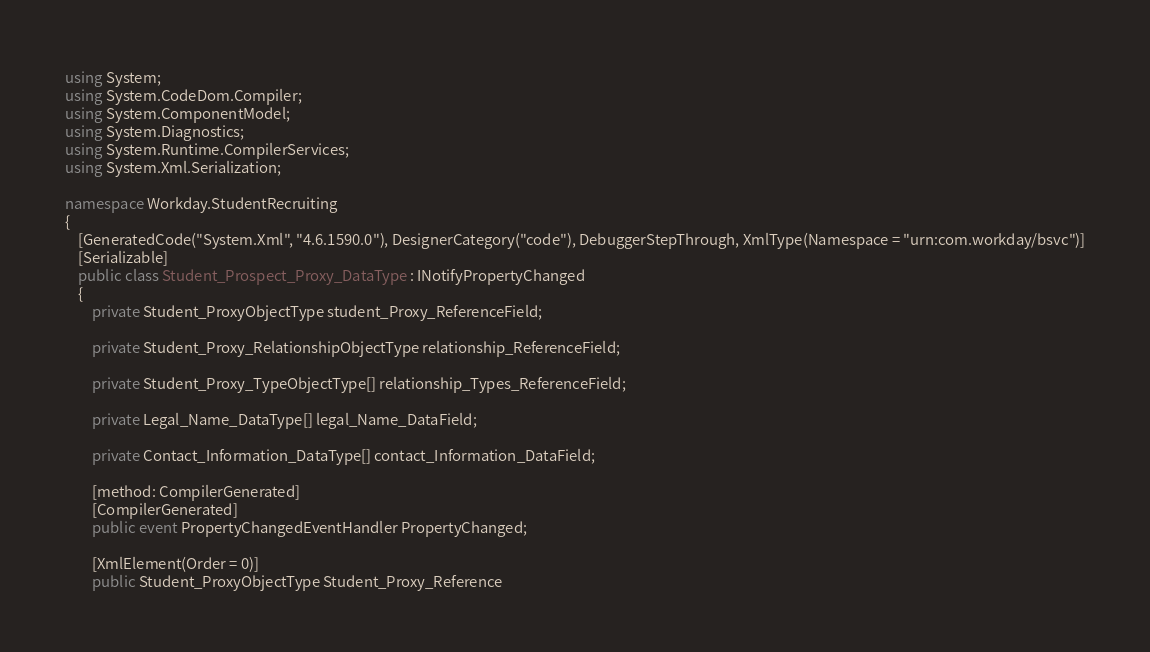Convert code to text. <code><loc_0><loc_0><loc_500><loc_500><_C#_>using System;
using System.CodeDom.Compiler;
using System.ComponentModel;
using System.Diagnostics;
using System.Runtime.CompilerServices;
using System.Xml.Serialization;

namespace Workday.StudentRecruiting
{
	[GeneratedCode("System.Xml", "4.6.1590.0"), DesignerCategory("code"), DebuggerStepThrough, XmlType(Namespace = "urn:com.workday/bsvc")]
	[Serializable]
	public class Student_Prospect_Proxy_DataType : INotifyPropertyChanged
	{
		private Student_ProxyObjectType student_Proxy_ReferenceField;

		private Student_Proxy_RelationshipObjectType relationship_ReferenceField;

		private Student_Proxy_TypeObjectType[] relationship_Types_ReferenceField;

		private Legal_Name_DataType[] legal_Name_DataField;

		private Contact_Information_DataType[] contact_Information_DataField;

		[method: CompilerGenerated]
		[CompilerGenerated]
		public event PropertyChangedEventHandler PropertyChanged;

		[XmlElement(Order = 0)]
		public Student_ProxyObjectType Student_Proxy_Reference</code> 